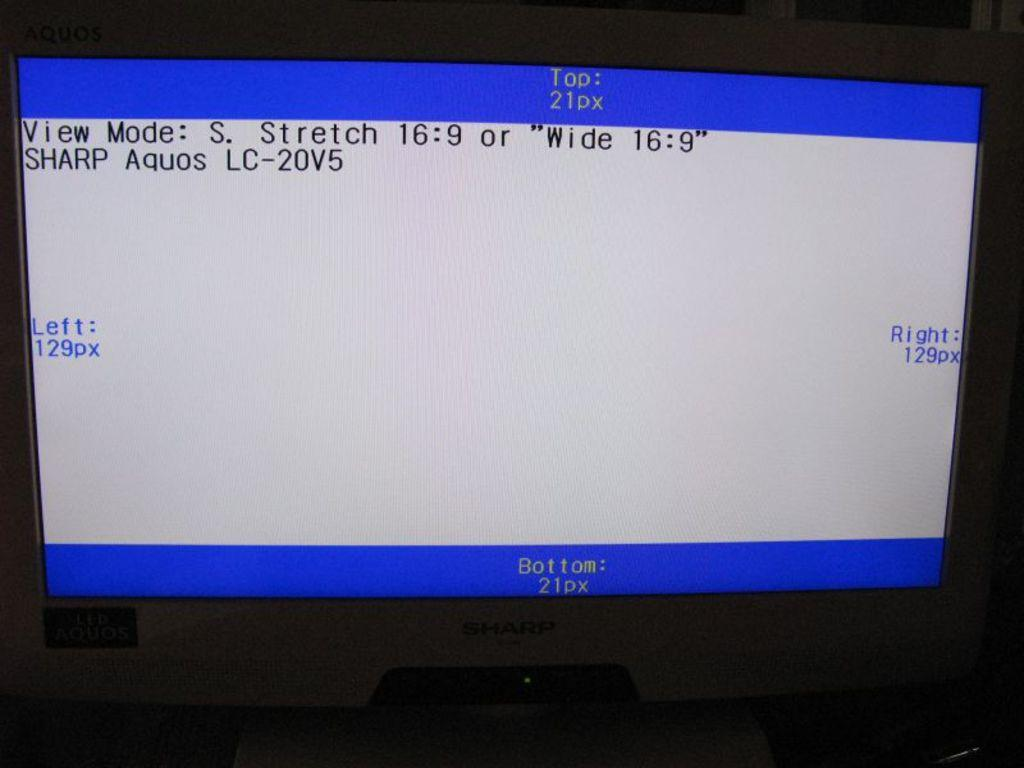<image>
Offer a succinct explanation of the picture presented. The view mode of a Sharp Aquos LC-20V5 shows the display properties. 